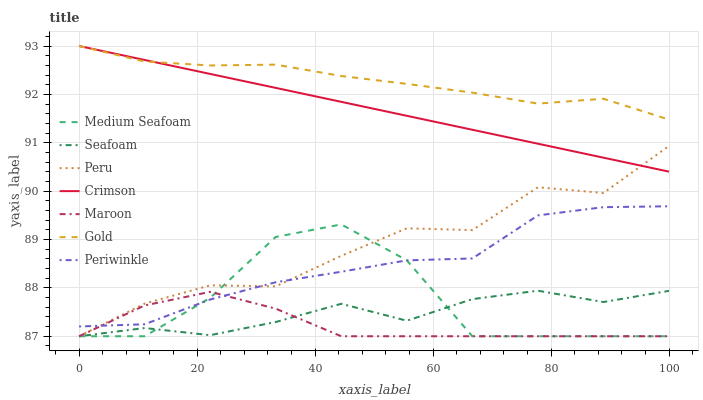Does Maroon have the minimum area under the curve?
Answer yes or no. Yes. Does Gold have the maximum area under the curve?
Answer yes or no. Yes. Does Seafoam have the minimum area under the curve?
Answer yes or no. No. Does Seafoam have the maximum area under the curve?
Answer yes or no. No. Is Crimson the smoothest?
Answer yes or no. Yes. Is Medium Seafoam the roughest?
Answer yes or no. Yes. Is Seafoam the smoothest?
Answer yes or no. No. Is Seafoam the roughest?
Answer yes or no. No. Does Seafoam have the lowest value?
Answer yes or no. Yes. Does Periwinkle have the lowest value?
Answer yes or no. No. Does Crimson have the highest value?
Answer yes or no. Yes. Does Seafoam have the highest value?
Answer yes or no. No. Is Maroon less than Crimson?
Answer yes or no. Yes. Is Crimson greater than Periwinkle?
Answer yes or no. Yes. Does Gold intersect Crimson?
Answer yes or no. Yes. Is Gold less than Crimson?
Answer yes or no. No. Is Gold greater than Crimson?
Answer yes or no. No. Does Maroon intersect Crimson?
Answer yes or no. No. 